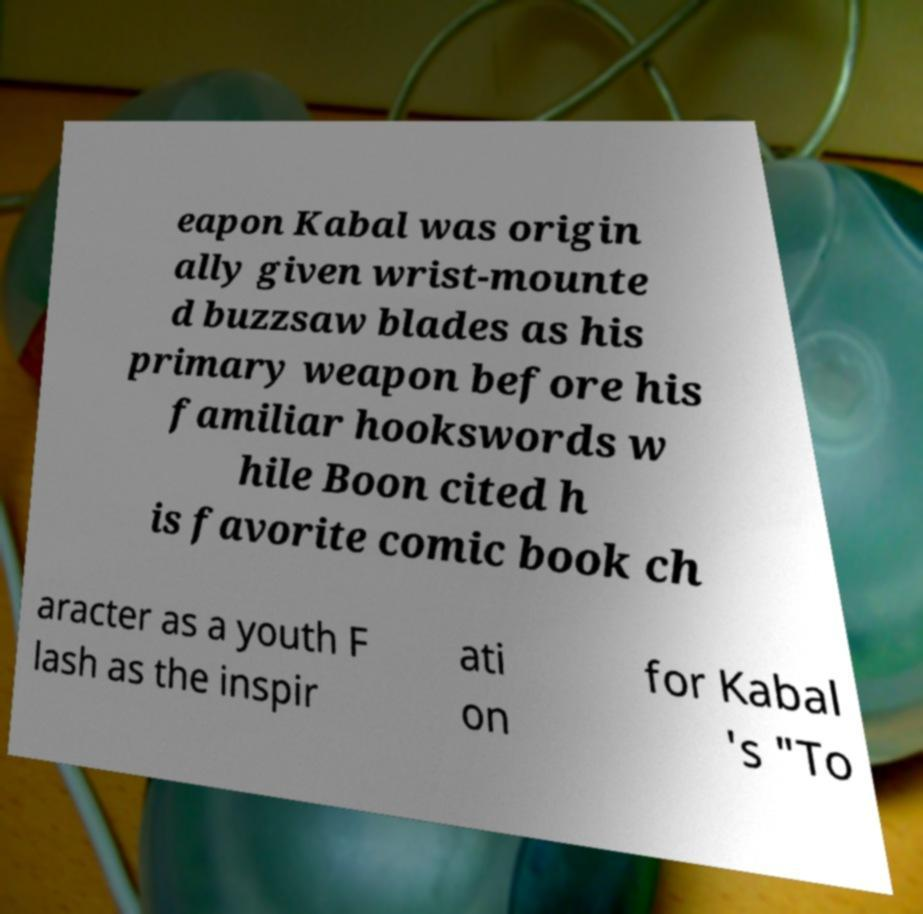Could you extract and type out the text from this image? eapon Kabal was origin ally given wrist-mounte d buzzsaw blades as his primary weapon before his familiar hookswords w hile Boon cited h is favorite comic book ch aracter as a youth F lash as the inspir ati on for Kabal 's "To 